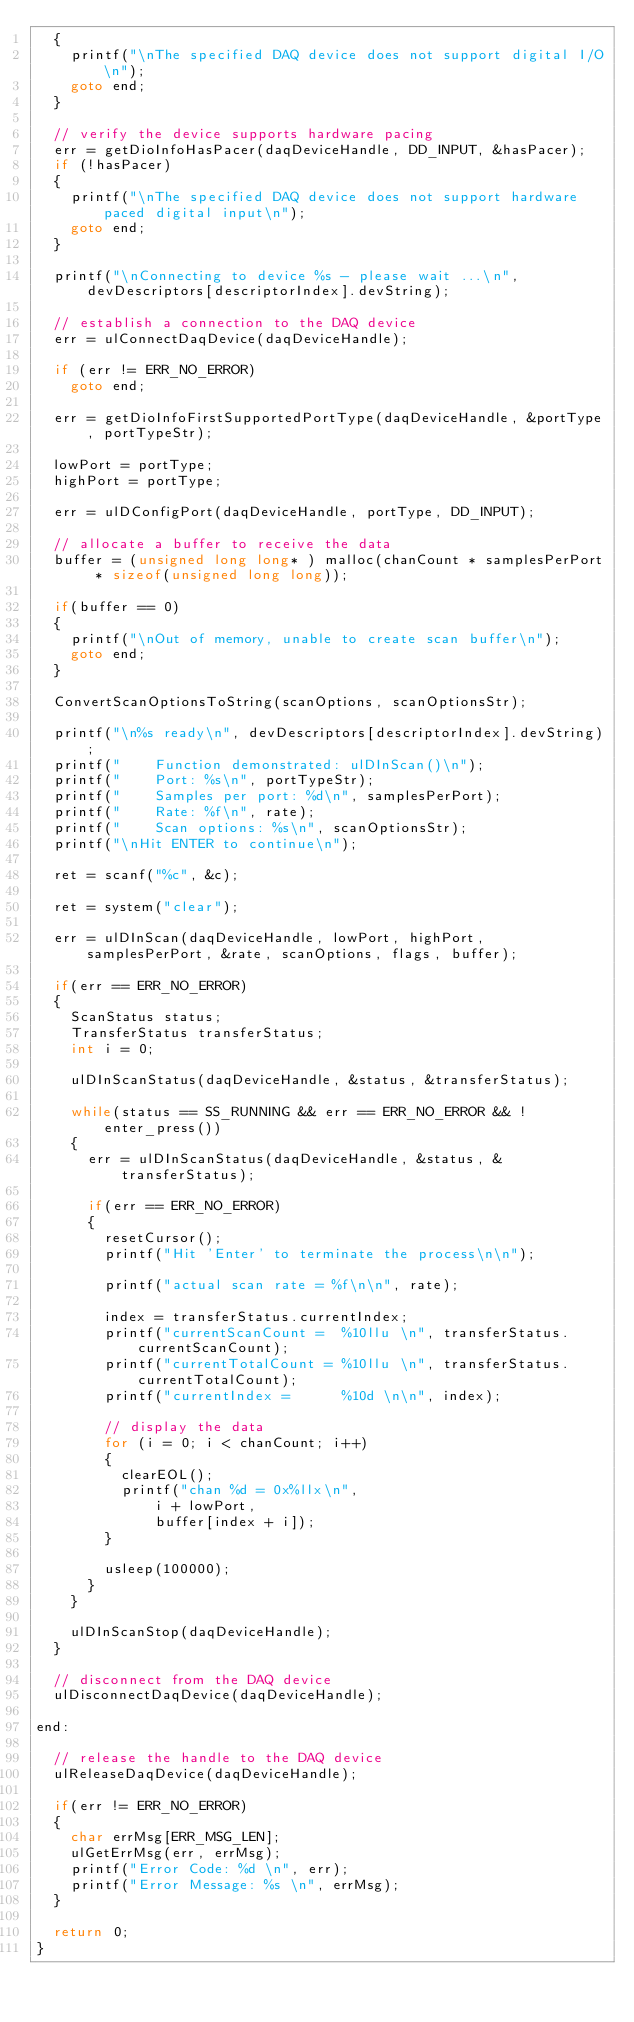Convert code to text. <code><loc_0><loc_0><loc_500><loc_500><_C_>	{
		printf("\nThe specified DAQ device does not support digital I/O\n");
		goto end;
	}

	// verify the device supports hardware pacing
	err = getDioInfoHasPacer(daqDeviceHandle, DD_INPUT, &hasPacer);
	if (!hasPacer)
	{
		printf("\nThe specified DAQ device does not support hardware paced digital input\n");
		goto end;
	}

	printf("\nConnecting to device %s - please wait ...\n", devDescriptors[descriptorIndex].devString);

	// establish a connection to the DAQ device
	err = ulConnectDaqDevice(daqDeviceHandle);

	if (err != ERR_NO_ERROR)
		goto end;

	err = getDioInfoFirstSupportedPortType(daqDeviceHandle, &portType, portTypeStr);

	lowPort = portType;
	highPort = portType;

	err = ulDConfigPort(daqDeviceHandle, portType, DD_INPUT);

	// allocate a buffer to receive the data
	buffer = (unsigned long long* ) malloc(chanCount * samplesPerPort * sizeof(unsigned long long));

	if(buffer == 0)
	{
		printf("\nOut of memory, unable to create scan buffer\n");
		goto end;
	}

	ConvertScanOptionsToString(scanOptions, scanOptionsStr);

	printf("\n%s ready\n", devDescriptors[descriptorIndex].devString);
	printf("    Function demonstrated: ulDInScan()\n");
	printf("    Port: %s\n", portTypeStr);
	printf("    Samples per port: %d\n", samplesPerPort);
	printf("    Rate: %f\n", rate);
	printf("    Scan options: %s\n", scanOptionsStr);
	printf("\nHit ENTER to continue\n");

	ret = scanf("%c", &c);

	ret = system("clear");

	err = ulDInScan(daqDeviceHandle, lowPort, highPort, samplesPerPort, &rate, scanOptions, flags, buffer);

	if(err == ERR_NO_ERROR)
	{
		ScanStatus status;
		TransferStatus transferStatus;
		int i = 0;

		ulDInScanStatus(daqDeviceHandle, &status, &transferStatus);

		while(status == SS_RUNNING && err == ERR_NO_ERROR && !enter_press())
		{
			err = ulDInScanStatus(daqDeviceHandle, &status, &transferStatus);

			if(err == ERR_NO_ERROR)
			{
				resetCursor();
				printf("Hit 'Enter' to terminate the process\n\n");

				printf("actual scan rate = %f\n\n", rate);

				index = transferStatus.currentIndex;
				printf("currentScanCount =  %10llu \n", transferStatus.currentScanCount);
				printf("currentTotalCount = %10llu \n", transferStatus.currentTotalCount);
				printf("currentIndex =      %10d \n\n", index);

				// display the data
				for (i = 0; i < chanCount; i++)
				{
					clearEOL();
					printf("chan %d = 0x%llx\n",
							i + lowPort,
							buffer[index + i]);
				}

				usleep(100000);
			}
		}

		ulDInScanStop(daqDeviceHandle);
	}

	// disconnect from the DAQ device
	ulDisconnectDaqDevice(daqDeviceHandle);

end:

	// release the handle to the DAQ device
	ulReleaseDaqDevice(daqDeviceHandle);

	if(err != ERR_NO_ERROR)
	{
		char errMsg[ERR_MSG_LEN];
		ulGetErrMsg(err, errMsg);
		printf("Error Code: %d \n", err);
		printf("Error Message: %s \n", errMsg);
	}

	return 0;
}
</code> 